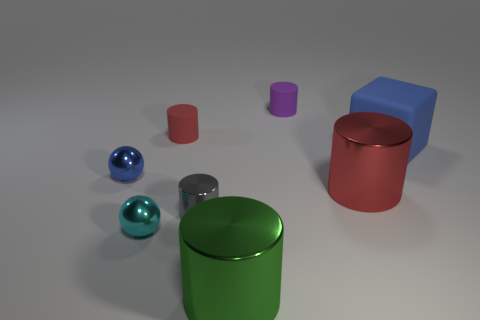Is there anything else that has the same shape as the blue matte object?
Ensure brevity in your answer.  No. What is the color of the small metal cylinder?
Your answer should be very brief. Gray. What number of cyan objects have the same shape as the small red rubber object?
Keep it short and to the point. 0. There is a sphere that is the same size as the blue metal thing; what is its color?
Offer a terse response. Cyan. Are there any small metallic blocks?
Ensure brevity in your answer.  No. What is the shape of the big object in front of the large red shiny object?
Give a very brief answer. Cylinder. How many matte things are behind the big blue matte object and right of the red metal cylinder?
Your answer should be compact. 0. Are there any green cylinders made of the same material as the big red thing?
Ensure brevity in your answer.  Yes. How many blocks are big shiny things or small metal things?
Give a very brief answer. 0. What size is the gray shiny object?
Provide a succinct answer. Small. 